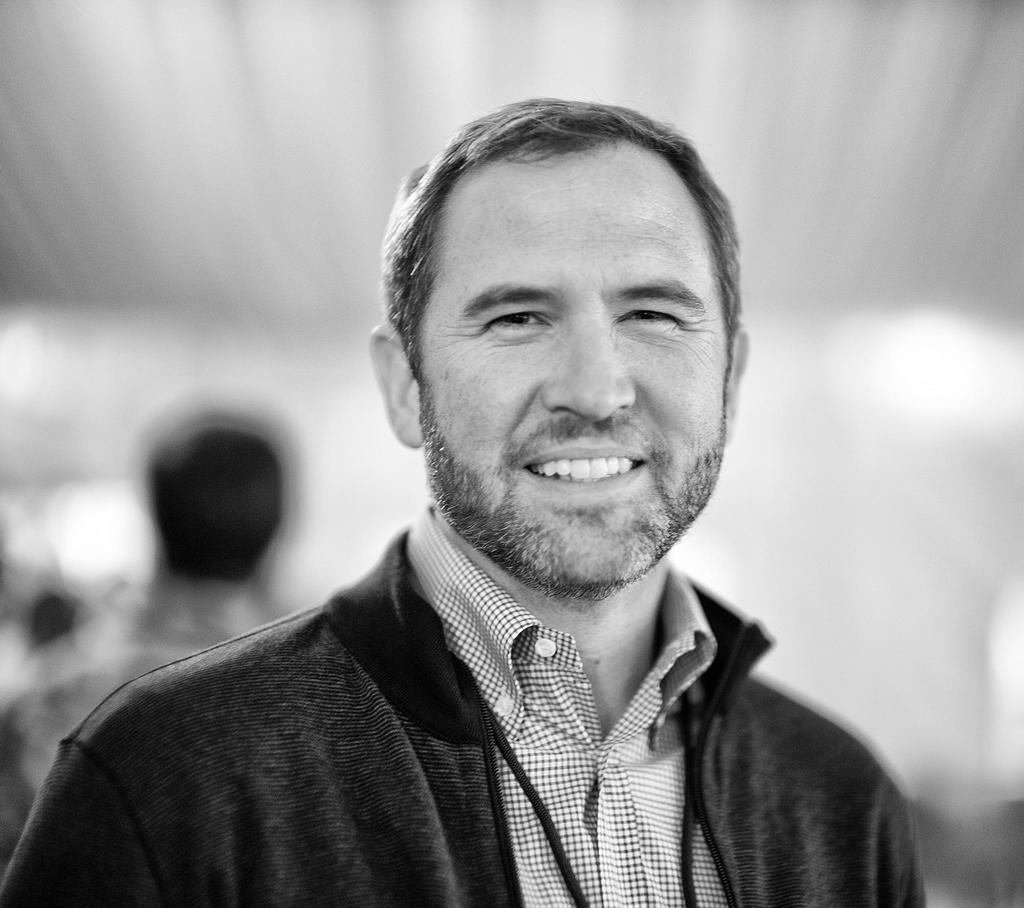What is the main subject in the foreground of the image? There is a person in the foreground of the image. What is the facial expression of the person in the foreground? The person in the foreground is smiling. Can you describe the person on the left side of the image? There is another person on the left side of the image. How would you describe the background of the image? The background of the image is blurry. What type of pet can be seen in the image? There is no pet present in the image. 